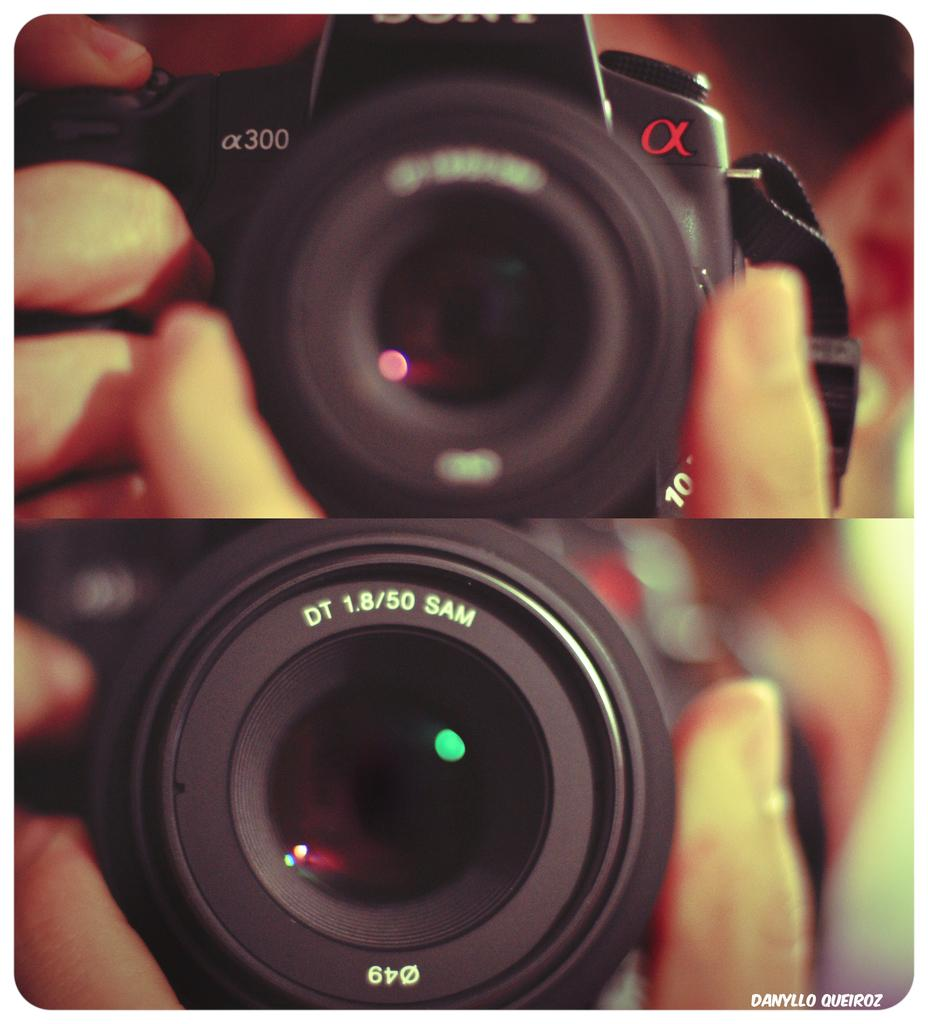What is the main subject of the image? There is a person in the image. What is the person holding in their hand? The person is holding a camera in their hand. Can you describe any text visible in the image? Yes, there is text visible in the image. How can you tell that the image might be edited? The image appears to be an edited photo. What type of rhythm can be heard in the background of the image? There is no audible rhythm present in the image, as it is a still photograph. 